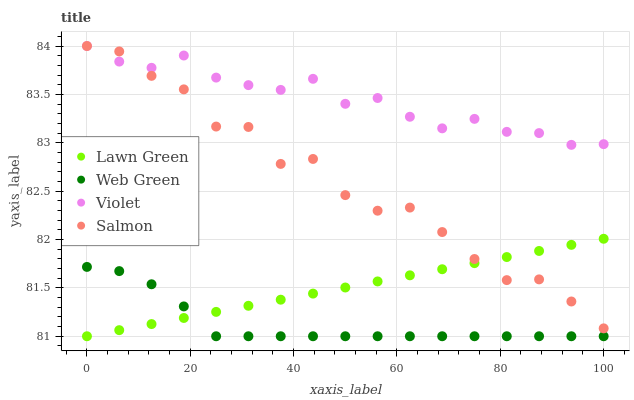Does Web Green have the minimum area under the curve?
Answer yes or no. Yes. Does Violet have the maximum area under the curve?
Answer yes or no. Yes. Does Salmon have the minimum area under the curve?
Answer yes or no. No. Does Salmon have the maximum area under the curve?
Answer yes or no. No. Is Lawn Green the smoothest?
Answer yes or no. Yes. Is Salmon the roughest?
Answer yes or no. Yes. Is Web Green the smoothest?
Answer yes or no. No. Is Web Green the roughest?
Answer yes or no. No. Does Lawn Green have the lowest value?
Answer yes or no. Yes. Does Salmon have the lowest value?
Answer yes or no. No. Does Violet have the highest value?
Answer yes or no. Yes. Does Web Green have the highest value?
Answer yes or no. No. Is Web Green less than Salmon?
Answer yes or no. Yes. Is Violet greater than Lawn Green?
Answer yes or no. Yes. Does Lawn Green intersect Salmon?
Answer yes or no. Yes. Is Lawn Green less than Salmon?
Answer yes or no. No. Is Lawn Green greater than Salmon?
Answer yes or no. No. Does Web Green intersect Salmon?
Answer yes or no. No. 